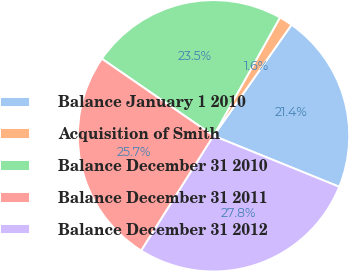<chart> <loc_0><loc_0><loc_500><loc_500><pie_chart><fcel>Balance January 1 2010<fcel>Acquisition of Smith<fcel>Balance December 31 2010<fcel>Balance December 31 2011<fcel>Balance December 31 2012<nl><fcel>21.39%<fcel>1.6%<fcel>23.53%<fcel>25.67%<fcel>27.81%<nl></chart> 